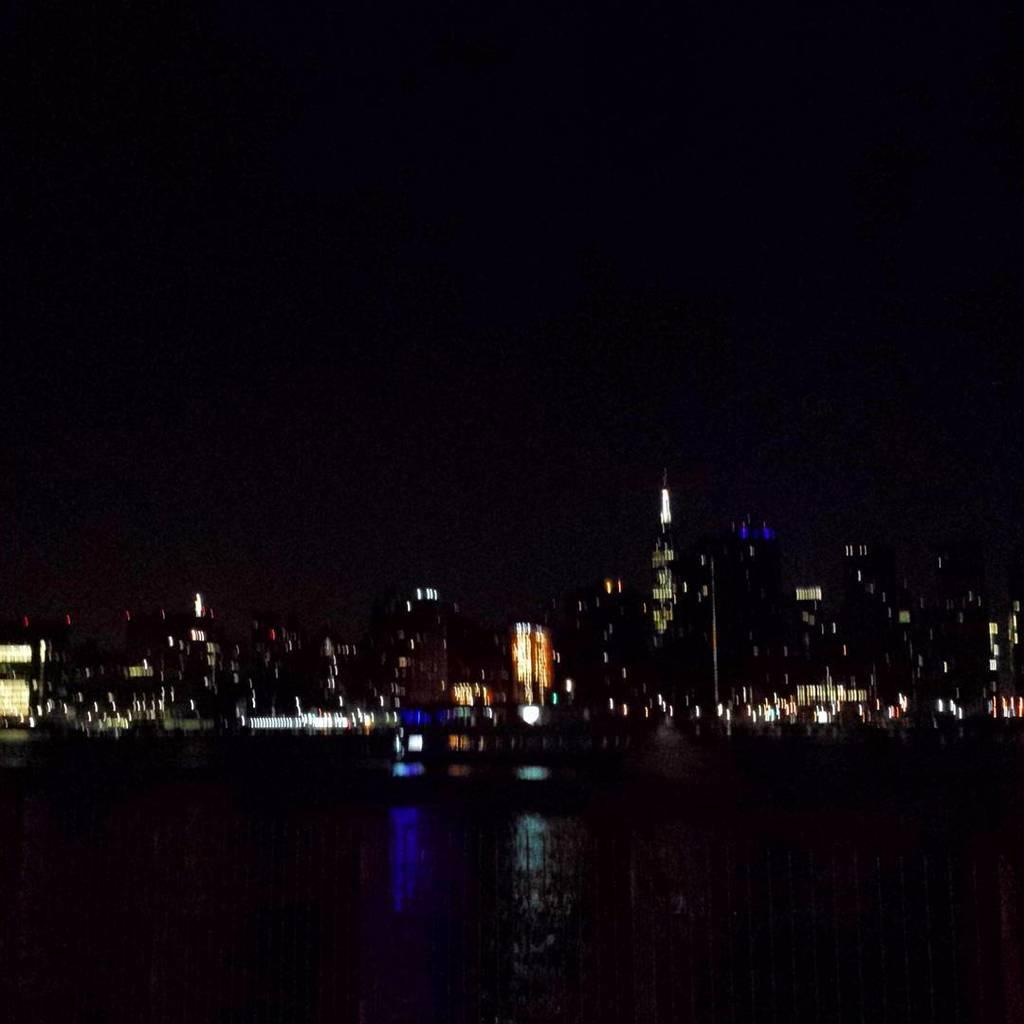What is the lighting condition in the image? The image was taken in the dark. What can be seen at the bottom of the image? There is water visible at the bottom of the image. What is visible in the background of the image? There are many buildings and lights in the background of the image. What type of insurance policy is being discussed in the image? There is no discussion of insurance policies in the image; it features water, buildings, and lights. Can you hear any songs being sung in the image? There is no audio in the image, so it is impossible to hear any songs being sung. 